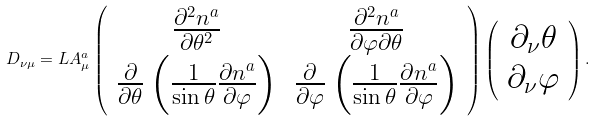<formula> <loc_0><loc_0><loc_500><loc_500>D _ { \nu \mu } = L A ^ { a } _ { \mu } \left ( \begin{array} { c c } \frac { \partial ^ { 2 } n ^ { a } } { \partial \theta ^ { 2 } } & \frac { \partial ^ { 2 } n ^ { a } } { \partial \varphi \partial \theta } \\ \frac { \partial } { \partial \theta } \left ( \frac { 1 } { \sin \theta } \frac { \partial n ^ { a } } { \partial \varphi } \right ) & \frac { \partial } { \partial \varphi } \left ( \frac { 1 } { \sin \theta } \frac { \partial n ^ { a } } { \partial \varphi } \right ) \end{array} \right ) \left ( \begin{array} { c } \partial _ { \nu } \theta \\ \partial _ { \nu } \varphi \end{array} \right ) .</formula> 